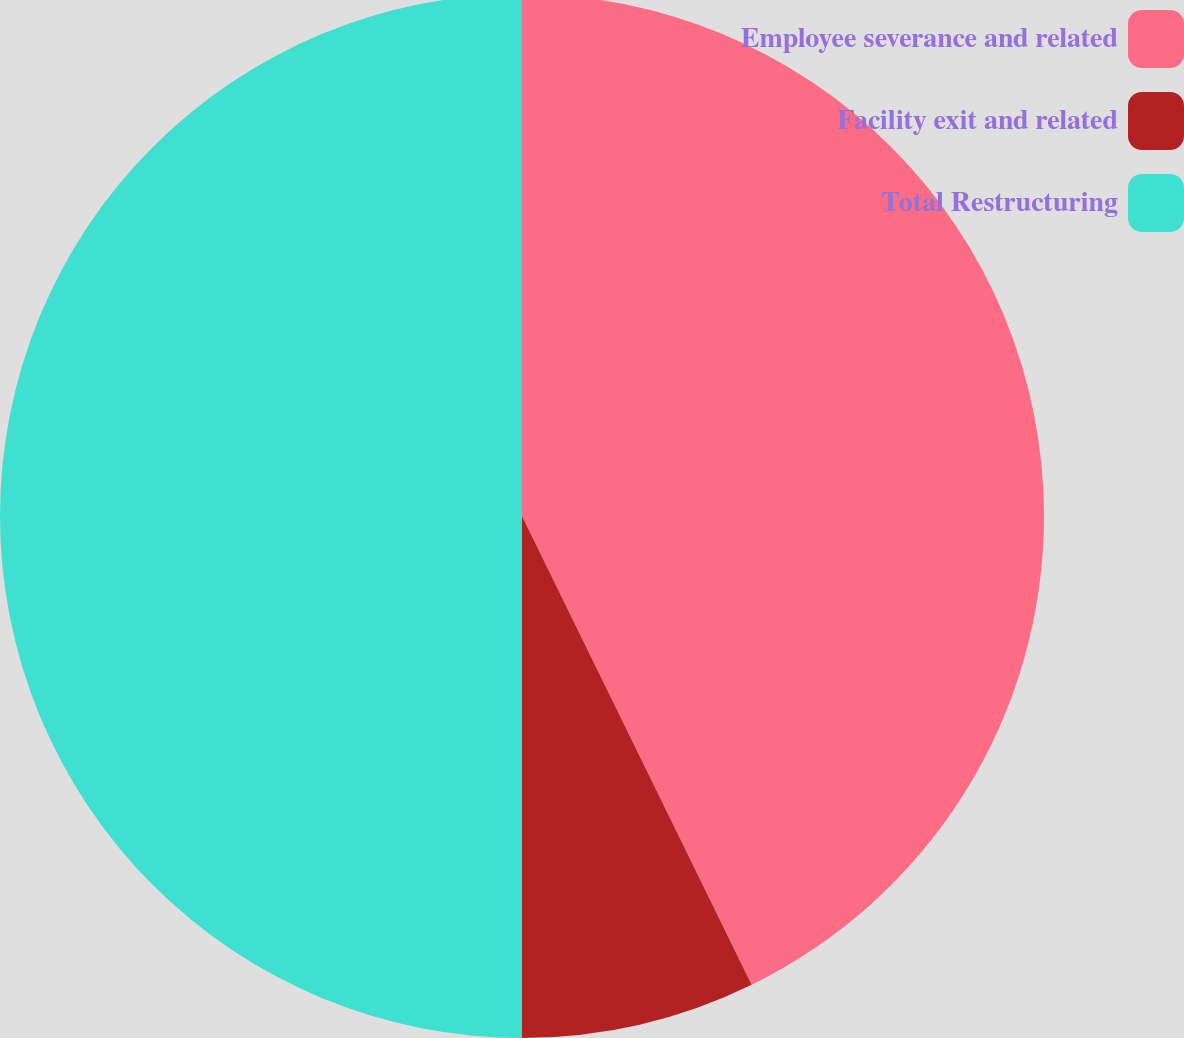<chart> <loc_0><loc_0><loc_500><loc_500><pie_chart><fcel>Employee severance and related<fcel>Facility exit and related<fcel>Total Restructuring<nl><fcel>42.75%<fcel>7.25%<fcel>50.0%<nl></chart> 